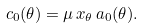<formula> <loc_0><loc_0><loc_500><loc_500>c _ { 0 } ( \theta ) = \mu \, x _ { \theta } \, a _ { 0 } ( \theta ) .</formula> 